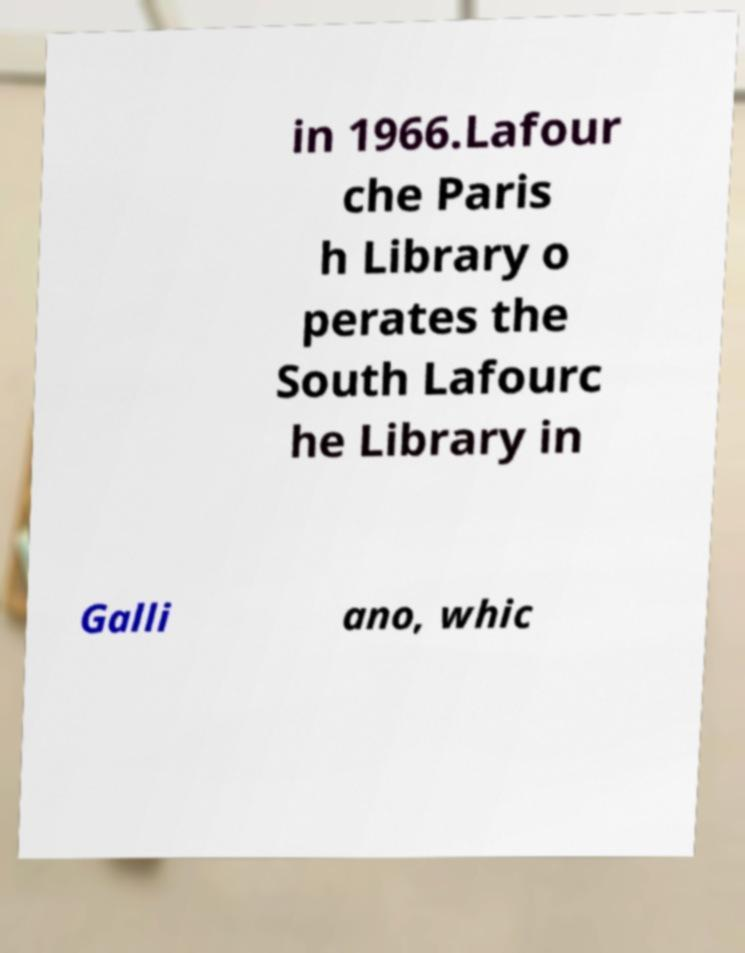For documentation purposes, I need the text within this image transcribed. Could you provide that? in 1966.Lafour che Paris h Library o perates the South Lafourc he Library in Galli ano, whic 